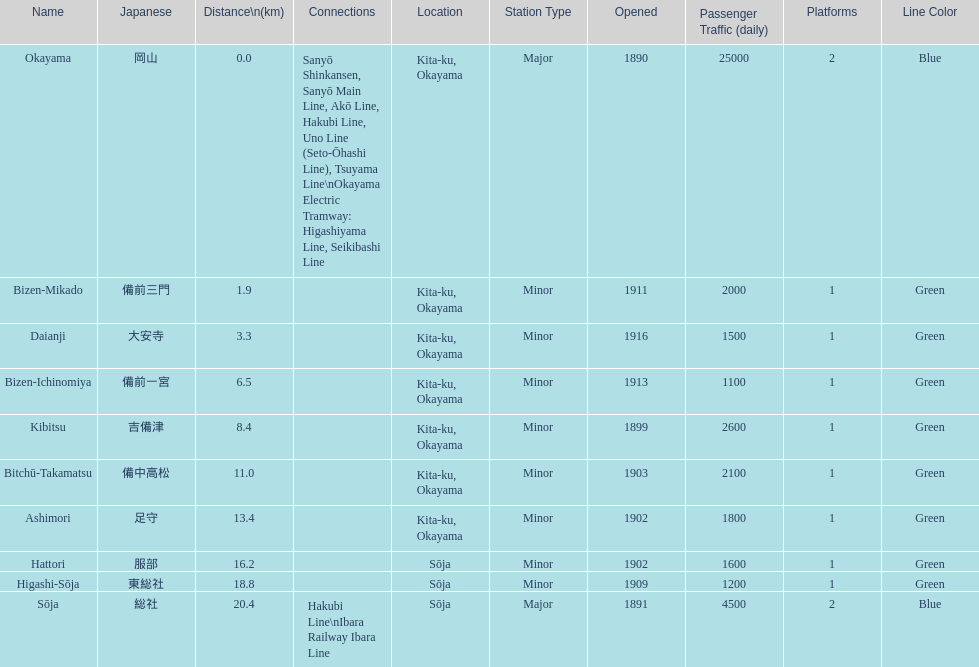Which has a distance less than 3.0 kilometers? Bizen-Mikado. 